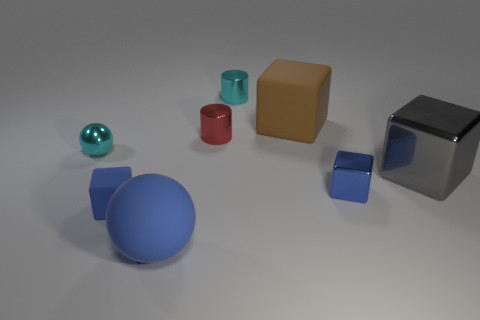There is a small sphere that is made of the same material as the gray cube; what is its color?
Provide a succinct answer. Cyan. How many tiny blocks are made of the same material as the red object?
Offer a terse response. 1. There is a tiny blue matte thing; how many large metal blocks are in front of it?
Give a very brief answer. 0. Are the cyan thing that is on the left side of the small matte block and the tiny cyan thing right of the red metallic object made of the same material?
Make the answer very short. Yes. Is the number of big things that are right of the metal ball greater than the number of small metal cylinders that are in front of the blue sphere?
Your response must be concise. Yes. There is another small thing that is the same color as the tiny rubber object; what is its material?
Make the answer very short. Metal. There is a big object that is both left of the gray metallic cube and to the right of the red shiny object; what is its material?
Keep it short and to the point. Rubber. Do the brown cube and the ball behind the gray metallic block have the same material?
Make the answer very short. No. What number of things are either big gray things or blue things on the left side of the big brown matte thing?
Offer a very short reply. 3. Does the shiny block that is to the right of the blue shiny block have the same size as the block that is in front of the tiny blue shiny cube?
Your answer should be compact. No. 